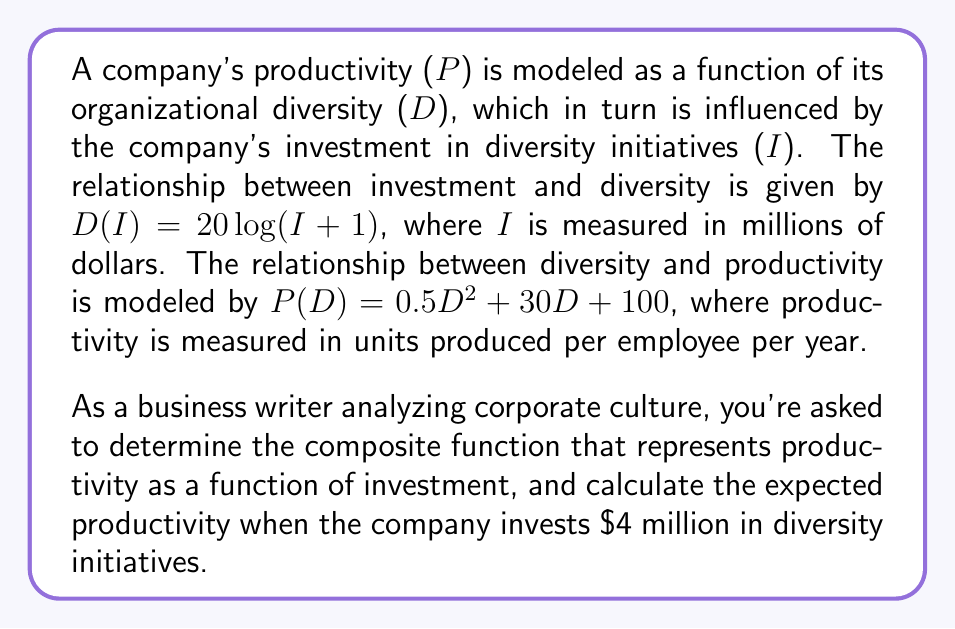Solve this math problem. To solve this problem, we need to follow these steps:

1. Identify the two functions given:
   $D(I) = 20\log(I+1)$
   $P(D) = 0.5D^2 + 30D + 100$

2. Create the composite function P(D(I)) to represent productivity as a function of investment:
   $P(D(I)) = P(20\log(I+1))$
   $P(D(I)) = 0.5(20\log(I+1))^2 + 30(20\log(I+1)) + 100$
   $P(D(I)) = 200(\log(I+1))^2 + 600\log(I+1) + 100$

3. Calculate the productivity when I = 4:
   $P(D(4)) = 200(\log(4+1))^2 + 600\log(4+1) + 100$
   $P(D(4)) = 200(\log(5))^2 + 600\log(5) + 100$
   $P(D(4)) = 200(0.699)^2 + 600(0.699) + 100$
   $P(D(4)) = 97.72 + 419.4 + 100$
   $P(D(4)) = 617.12$

Therefore, when the company invests $4 million in diversity initiatives, the expected productivity is approximately 617 units produced per employee per year.
Answer: The composite function representing productivity as a function of investment is:
$$P(D(I)) = 200(\log(I+1))^2 + 600\log(I+1) + 100$$

When the company invests $4 million in diversity initiatives, the expected productivity is approximately 617 units produced per employee per year. 